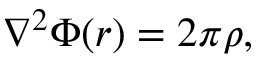Convert formula to latex. <formula><loc_0><loc_0><loc_500><loc_500>\nabla ^ { 2 } \Phi ( r ) = 2 \pi \rho ,</formula> 